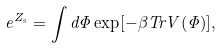<formula> <loc_0><loc_0><loc_500><loc_500>e ^ { Z _ { s } } = \int d \Phi \exp [ - \beta T r V ( \Phi ) ] ,</formula> 